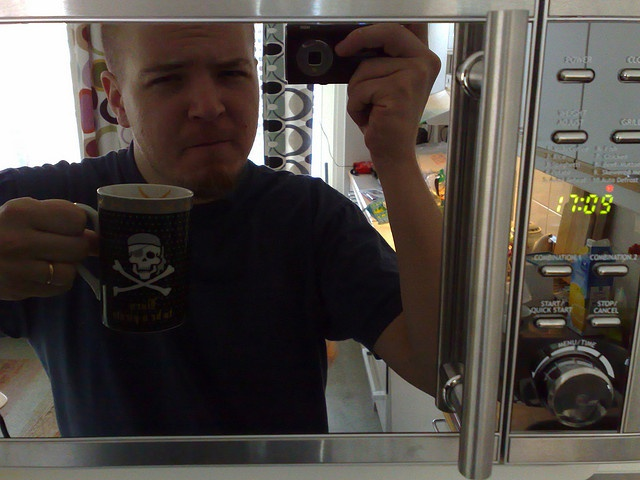Describe the objects in this image and their specific colors. I can see microwave in black, gray, maroon, darkgray, and white tones, people in white, black, maroon, and gray tones, cup in white, black, gray, and maroon tones, cell phone in white, black, gray, maroon, and darkgray tones, and clock in white, olive, gray, black, and tan tones in this image. 